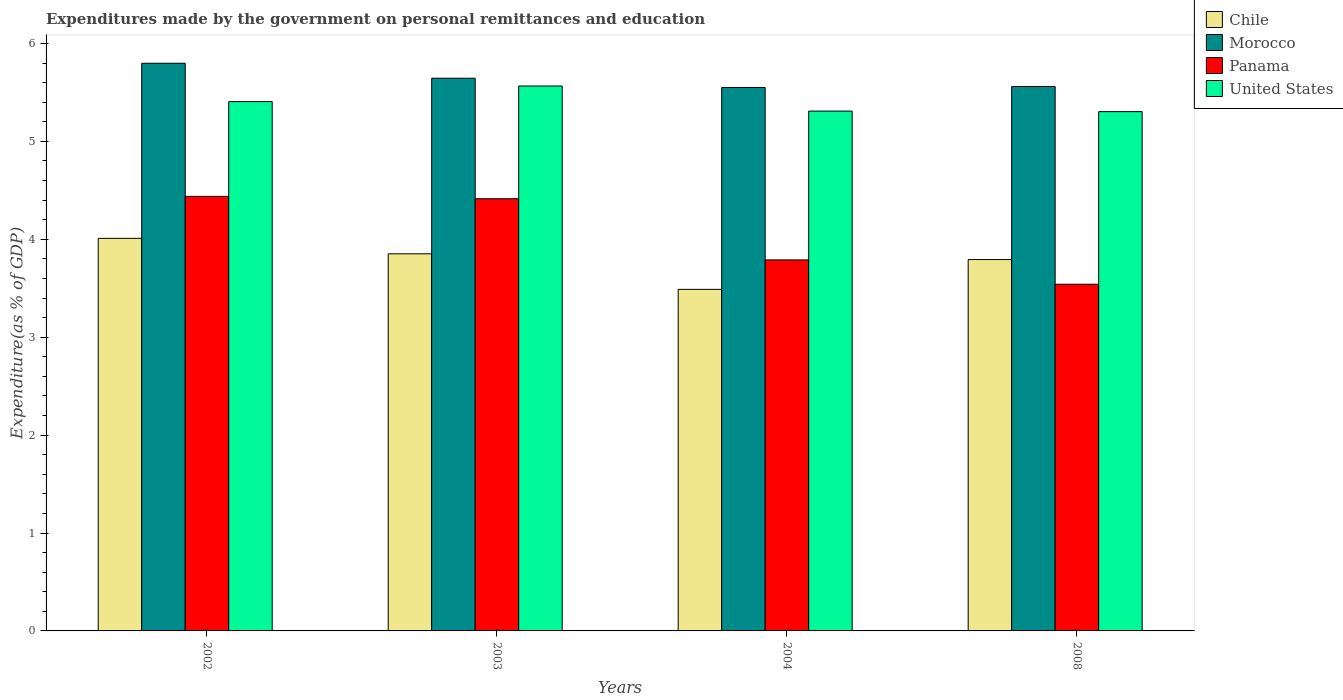How many different coloured bars are there?
Provide a succinct answer. 4. Are the number of bars per tick equal to the number of legend labels?
Your answer should be very brief. Yes. How many bars are there on the 4th tick from the left?
Ensure brevity in your answer.  4. In how many cases, is the number of bars for a given year not equal to the number of legend labels?
Your answer should be very brief. 0. What is the expenditures made by the government on personal remittances and education in Chile in 2004?
Offer a very short reply. 3.49. Across all years, what is the maximum expenditures made by the government on personal remittances and education in Panama?
Offer a very short reply. 4.44. Across all years, what is the minimum expenditures made by the government on personal remittances and education in Panama?
Provide a succinct answer. 3.54. What is the total expenditures made by the government on personal remittances and education in Panama in the graph?
Your answer should be very brief. 16.18. What is the difference between the expenditures made by the government on personal remittances and education in United States in 2002 and that in 2008?
Provide a succinct answer. 0.1. What is the difference between the expenditures made by the government on personal remittances and education in Panama in 2008 and the expenditures made by the government on personal remittances and education in United States in 2002?
Give a very brief answer. -1.87. What is the average expenditures made by the government on personal remittances and education in Morocco per year?
Ensure brevity in your answer.  5.64. In the year 2004, what is the difference between the expenditures made by the government on personal remittances and education in Chile and expenditures made by the government on personal remittances and education in Panama?
Offer a very short reply. -0.3. In how many years, is the expenditures made by the government on personal remittances and education in United States greater than 3.2 %?
Provide a short and direct response. 4. What is the ratio of the expenditures made by the government on personal remittances and education in Morocco in 2002 to that in 2008?
Your answer should be very brief. 1.04. Is the expenditures made by the government on personal remittances and education in United States in 2002 less than that in 2004?
Make the answer very short. No. What is the difference between the highest and the second highest expenditures made by the government on personal remittances and education in United States?
Ensure brevity in your answer.  0.16. What is the difference between the highest and the lowest expenditures made by the government on personal remittances and education in Chile?
Provide a succinct answer. 0.52. Is it the case that in every year, the sum of the expenditures made by the government on personal remittances and education in Morocco and expenditures made by the government on personal remittances and education in United States is greater than the sum of expenditures made by the government on personal remittances and education in Chile and expenditures made by the government on personal remittances and education in Panama?
Provide a short and direct response. Yes. What does the 2nd bar from the right in 2008 represents?
Your answer should be compact. Panama. Is it the case that in every year, the sum of the expenditures made by the government on personal remittances and education in Chile and expenditures made by the government on personal remittances and education in Morocco is greater than the expenditures made by the government on personal remittances and education in Panama?
Offer a very short reply. Yes. Are all the bars in the graph horizontal?
Offer a very short reply. No. How many years are there in the graph?
Your answer should be very brief. 4. Are the values on the major ticks of Y-axis written in scientific E-notation?
Ensure brevity in your answer.  No. How many legend labels are there?
Offer a very short reply. 4. How are the legend labels stacked?
Make the answer very short. Vertical. What is the title of the graph?
Make the answer very short. Expenditures made by the government on personal remittances and education. Does "Macao" appear as one of the legend labels in the graph?
Provide a short and direct response. No. What is the label or title of the X-axis?
Your response must be concise. Years. What is the label or title of the Y-axis?
Your answer should be compact. Expenditure(as % of GDP). What is the Expenditure(as % of GDP) in Chile in 2002?
Give a very brief answer. 4.01. What is the Expenditure(as % of GDP) in Morocco in 2002?
Make the answer very short. 5.8. What is the Expenditure(as % of GDP) of Panama in 2002?
Keep it short and to the point. 4.44. What is the Expenditure(as % of GDP) in United States in 2002?
Make the answer very short. 5.41. What is the Expenditure(as % of GDP) of Chile in 2003?
Provide a short and direct response. 3.85. What is the Expenditure(as % of GDP) of Morocco in 2003?
Ensure brevity in your answer.  5.64. What is the Expenditure(as % of GDP) of Panama in 2003?
Provide a short and direct response. 4.41. What is the Expenditure(as % of GDP) of United States in 2003?
Provide a short and direct response. 5.57. What is the Expenditure(as % of GDP) in Chile in 2004?
Ensure brevity in your answer.  3.49. What is the Expenditure(as % of GDP) of Morocco in 2004?
Offer a terse response. 5.55. What is the Expenditure(as % of GDP) of Panama in 2004?
Your response must be concise. 3.79. What is the Expenditure(as % of GDP) of United States in 2004?
Your response must be concise. 5.31. What is the Expenditure(as % of GDP) in Chile in 2008?
Provide a short and direct response. 3.79. What is the Expenditure(as % of GDP) in Morocco in 2008?
Provide a short and direct response. 5.56. What is the Expenditure(as % of GDP) in Panama in 2008?
Make the answer very short. 3.54. What is the Expenditure(as % of GDP) in United States in 2008?
Provide a short and direct response. 5.3. Across all years, what is the maximum Expenditure(as % of GDP) in Chile?
Your answer should be compact. 4.01. Across all years, what is the maximum Expenditure(as % of GDP) in Morocco?
Offer a terse response. 5.8. Across all years, what is the maximum Expenditure(as % of GDP) in Panama?
Offer a very short reply. 4.44. Across all years, what is the maximum Expenditure(as % of GDP) of United States?
Make the answer very short. 5.57. Across all years, what is the minimum Expenditure(as % of GDP) in Chile?
Provide a succinct answer. 3.49. Across all years, what is the minimum Expenditure(as % of GDP) in Morocco?
Your response must be concise. 5.55. Across all years, what is the minimum Expenditure(as % of GDP) of Panama?
Your response must be concise. 3.54. Across all years, what is the minimum Expenditure(as % of GDP) in United States?
Offer a very short reply. 5.3. What is the total Expenditure(as % of GDP) in Chile in the graph?
Provide a short and direct response. 15.14. What is the total Expenditure(as % of GDP) in Morocco in the graph?
Keep it short and to the point. 22.55. What is the total Expenditure(as % of GDP) of Panama in the graph?
Keep it short and to the point. 16.18. What is the total Expenditure(as % of GDP) of United States in the graph?
Ensure brevity in your answer.  21.58. What is the difference between the Expenditure(as % of GDP) of Chile in 2002 and that in 2003?
Offer a very short reply. 0.16. What is the difference between the Expenditure(as % of GDP) in Morocco in 2002 and that in 2003?
Offer a terse response. 0.15. What is the difference between the Expenditure(as % of GDP) in Panama in 2002 and that in 2003?
Offer a terse response. 0.02. What is the difference between the Expenditure(as % of GDP) in United States in 2002 and that in 2003?
Your answer should be very brief. -0.16. What is the difference between the Expenditure(as % of GDP) in Chile in 2002 and that in 2004?
Offer a very short reply. 0.52. What is the difference between the Expenditure(as % of GDP) of Morocco in 2002 and that in 2004?
Make the answer very short. 0.25. What is the difference between the Expenditure(as % of GDP) in Panama in 2002 and that in 2004?
Provide a short and direct response. 0.65. What is the difference between the Expenditure(as % of GDP) in United States in 2002 and that in 2004?
Offer a terse response. 0.1. What is the difference between the Expenditure(as % of GDP) in Chile in 2002 and that in 2008?
Provide a succinct answer. 0.22. What is the difference between the Expenditure(as % of GDP) in Morocco in 2002 and that in 2008?
Your answer should be compact. 0.24. What is the difference between the Expenditure(as % of GDP) in Panama in 2002 and that in 2008?
Your answer should be compact. 0.9. What is the difference between the Expenditure(as % of GDP) of United States in 2002 and that in 2008?
Provide a short and direct response. 0.1. What is the difference between the Expenditure(as % of GDP) in Chile in 2003 and that in 2004?
Your answer should be compact. 0.36. What is the difference between the Expenditure(as % of GDP) in Morocco in 2003 and that in 2004?
Make the answer very short. 0.09. What is the difference between the Expenditure(as % of GDP) in Panama in 2003 and that in 2004?
Keep it short and to the point. 0.62. What is the difference between the Expenditure(as % of GDP) of United States in 2003 and that in 2004?
Your response must be concise. 0.26. What is the difference between the Expenditure(as % of GDP) in Chile in 2003 and that in 2008?
Offer a terse response. 0.06. What is the difference between the Expenditure(as % of GDP) of Morocco in 2003 and that in 2008?
Your answer should be compact. 0.08. What is the difference between the Expenditure(as % of GDP) of Panama in 2003 and that in 2008?
Provide a succinct answer. 0.87. What is the difference between the Expenditure(as % of GDP) of United States in 2003 and that in 2008?
Provide a short and direct response. 0.26. What is the difference between the Expenditure(as % of GDP) of Chile in 2004 and that in 2008?
Provide a succinct answer. -0.3. What is the difference between the Expenditure(as % of GDP) in Morocco in 2004 and that in 2008?
Ensure brevity in your answer.  -0.01. What is the difference between the Expenditure(as % of GDP) of Panama in 2004 and that in 2008?
Your response must be concise. 0.25. What is the difference between the Expenditure(as % of GDP) of United States in 2004 and that in 2008?
Provide a short and direct response. 0.01. What is the difference between the Expenditure(as % of GDP) of Chile in 2002 and the Expenditure(as % of GDP) of Morocco in 2003?
Make the answer very short. -1.64. What is the difference between the Expenditure(as % of GDP) in Chile in 2002 and the Expenditure(as % of GDP) in Panama in 2003?
Offer a very short reply. -0.4. What is the difference between the Expenditure(as % of GDP) in Chile in 2002 and the Expenditure(as % of GDP) in United States in 2003?
Provide a short and direct response. -1.56. What is the difference between the Expenditure(as % of GDP) of Morocco in 2002 and the Expenditure(as % of GDP) of Panama in 2003?
Ensure brevity in your answer.  1.38. What is the difference between the Expenditure(as % of GDP) in Morocco in 2002 and the Expenditure(as % of GDP) in United States in 2003?
Keep it short and to the point. 0.23. What is the difference between the Expenditure(as % of GDP) of Panama in 2002 and the Expenditure(as % of GDP) of United States in 2003?
Offer a very short reply. -1.13. What is the difference between the Expenditure(as % of GDP) in Chile in 2002 and the Expenditure(as % of GDP) in Morocco in 2004?
Offer a very short reply. -1.54. What is the difference between the Expenditure(as % of GDP) of Chile in 2002 and the Expenditure(as % of GDP) of Panama in 2004?
Provide a succinct answer. 0.22. What is the difference between the Expenditure(as % of GDP) in Chile in 2002 and the Expenditure(as % of GDP) in United States in 2004?
Your answer should be very brief. -1.3. What is the difference between the Expenditure(as % of GDP) in Morocco in 2002 and the Expenditure(as % of GDP) in Panama in 2004?
Make the answer very short. 2.01. What is the difference between the Expenditure(as % of GDP) in Morocco in 2002 and the Expenditure(as % of GDP) in United States in 2004?
Your answer should be very brief. 0.49. What is the difference between the Expenditure(as % of GDP) in Panama in 2002 and the Expenditure(as % of GDP) in United States in 2004?
Provide a short and direct response. -0.87. What is the difference between the Expenditure(as % of GDP) of Chile in 2002 and the Expenditure(as % of GDP) of Morocco in 2008?
Offer a very short reply. -1.55. What is the difference between the Expenditure(as % of GDP) of Chile in 2002 and the Expenditure(as % of GDP) of Panama in 2008?
Provide a short and direct response. 0.47. What is the difference between the Expenditure(as % of GDP) of Chile in 2002 and the Expenditure(as % of GDP) of United States in 2008?
Give a very brief answer. -1.29. What is the difference between the Expenditure(as % of GDP) of Morocco in 2002 and the Expenditure(as % of GDP) of Panama in 2008?
Provide a short and direct response. 2.26. What is the difference between the Expenditure(as % of GDP) in Morocco in 2002 and the Expenditure(as % of GDP) in United States in 2008?
Your answer should be compact. 0.49. What is the difference between the Expenditure(as % of GDP) of Panama in 2002 and the Expenditure(as % of GDP) of United States in 2008?
Your response must be concise. -0.87. What is the difference between the Expenditure(as % of GDP) of Chile in 2003 and the Expenditure(as % of GDP) of Morocco in 2004?
Your answer should be very brief. -1.7. What is the difference between the Expenditure(as % of GDP) in Chile in 2003 and the Expenditure(as % of GDP) in Panama in 2004?
Offer a very short reply. 0.06. What is the difference between the Expenditure(as % of GDP) of Chile in 2003 and the Expenditure(as % of GDP) of United States in 2004?
Offer a very short reply. -1.46. What is the difference between the Expenditure(as % of GDP) in Morocco in 2003 and the Expenditure(as % of GDP) in Panama in 2004?
Provide a succinct answer. 1.86. What is the difference between the Expenditure(as % of GDP) of Morocco in 2003 and the Expenditure(as % of GDP) of United States in 2004?
Make the answer very short. 0.34. What is the difference between the Expenditure(as % of GDP) of Panama in 2003 and the Expenditure(as % of GDP) of United States in 2004?
Your answer should be very brief. -0.9. What is the difference between the Expenditure(as % of GDP) in Chile in 2003 and the Expenditure(as % of GDP) in Morocco in 2008?
Provide a succinct answer. -1.71. What is the difference between the Expenditure(as % of GDP) in Chile in 2003 and the Expenditure(as % of GDP) in Panama in 2008?
Provide a succinct answer. 0.31. What is the difference between the Expenditure(as % of GDP) in Chile in 2003 and the Expenditure(as % of GDP) in United States in 2008?
Provide a succinct answer. -1.45. What is the difference between the Expenditure(as % of GDP) in Morocco in 2003 and the Expenditure(as % of GDP) in Panama in 2008?
Keep it short and to the point. 2.1. What is the difference between the Expenditure(as % of GDP) in Morocco in 2003 and the Expenditure(as % of GDP) in United States in 2008?
Keep it short and to the point. 0.34. What is the difference between the Expenditure(as % of GDP) in Panama in 2003 and the Expenditure(as % of GDP) in United States in 2008?
Give a very brief answer. -0.89. What is the difference between the Expenditure(as % of GDP) of Chile in 2004 and the Expenditure(as % of GDP) of Morocco in 2008?
Your answer should be very brief. -2.07. What is the difference between the Expenditure(as % of GDP) in Chile in 2004 and the Expenditure(as % of GDP) in Panama in 2008?
Offer a terse response. -0.05. What is the difference between the Expenditure(as % of GDP) of Chile in 2004 and the Expenditure(as % of GDP) of United States in 2008?
Provide a short and direct response. -1.82. What is the difference between the Expenditure(as % of GDP) in Morocco in 2004 and the Expenditure(as % of GDP) in Panama in 2008?
Offer a very short reply. 2.01. What is the difference between the Expenditure(as % of GDP) in Morocco in 2004 and the Expenditure(as % of GDP) in United States in 2008?
Provide a short and direct response. 0.25. What is the difference between the Expenditure(as % of GDP) of Panama in 2004 and the Expenditure(as % of GDP) of United States in 2008?
Give a very brief answer. -1.51. What is the average Expenditure(as % of GDP) in Chile per year?
Provide a short and direct response. 3.79. What is the average Expenditure(as % of GDP) in Morocco per year?
Your response must be concise. 5.64. What is the average Expenditure(as % of GDP) of Panama per year?
Offer a terse response. 4.05. What is the average Expenditure(as % of GDP) in United States per year?
Offer a terse response. 5.4. In the year 2002, what is the difference between the Expenditure(as % of GDP) of Chile and Expenditure(as % of GDP) of Morocco?
Offer a terse response. -1.79. In the year 2002, what is the difference between the Expenditure(as % of GDP) in Chile and Expenditure(as % of GDP) in Panama?
Offer a very short reply. -0.43. In the year 2002, what is the difference between the Expenditure(as % of GDP) of Chile and Expenditure(as % of GDP) of United States?
Keep it short and to the point. -1.4. In the year 2002, what is the difference between the Expenditure(as % of GDP) of Morocco and Expenditure(as % of GDP) of Panama?
Your answer should be very brief. 1.36. In the year 2002, what is the difference between the Expenditure(as % of GDP) in Morocco and Expenditure(as % of GDP) in United States?
Give a very brief answer. 0.39. In the year 2002, what is the difference between the Expenditure(as % of GDP) in Panama and Expenditure(as % of GDP) in United States?
Make the answer very short. -0.97. In the year 2003, what is the difference between the Expenditure(as % of GDP) of Chile and Expenditure(as % of GDP) of Morocco?
Provide a succinct answer. -1.79. In the year 2003, what is the difference between the Expenditure(as % of GDP) of Chile and Expenditure(as % of GDP) of Panama?
Offer a very short reply. -0.56. In the year 2003, what is the difference between the Expenditure(as % of GDP) of Chile and Expenditure(as % of GDP) of United States?
Provide a succinct answer. -1.71. In the year 2003, what is the difference between the Expenditure(as % of GDP) of Morocco and Expenditure(as % of GDP) of Panama?
Provide a succinct answer. 1.23. In the year 2003, what is the difference between the Expenditure(as % of GDP) in Morocco and Expenditure(as % of GDP) in United States?
Ensure brevity in your answer.  0.08. In the year 2003, what is the difference between the Expenditure(as % of GDP) in Panama and Expenditure(as % of GDP) in United States?
Make the answer very short. -1.15. In the year 2004, what is the difference between the Expenditure(as % of GDP) of Chile and Expenditure(as % of GDP) of Morocco?
Provide a succinct answer. -2.06. In the year 2004, what is the difference between the Expenditure(as % of GDP) of Chile and Expenditure(as % of GDP) of Panama?
Your response must be concise. -0.3. In the year 2004, what is the difference between the Expenditure(as % of GDP) in Chile and Expenditure(as % of GDP) in United States?
Make the answer very short. -1.82. In the year 2004, what is the difference between the Expenditure(as % of GDP) of Morocco and Expenditure(as % of GDP) of Panama?
Provide a short and direct response. 1.76. In the year 2004, what is the difference between the Expenditure(as % of GDP) in Morocco and Expenditure(as % of GDP) in United States?
Ensure brevity in your answer.  0.24. In the year 2004, what is the difference between the Expenditure(as % of GDP) in Panama and Expenditure(as % of GDP) in United States?
Provide a short and direct response. -1.52. In the year 2008, what is the difference between the Expenditure(as % of GDP) in Chile and Expenditure(as % of GDP) in Morocco?
Offer a terse response. -1.77. In the year 2008, what is the difference between the Expenditure(as % of GDP) in Chile and Expenditure(as % of GDP) in Panama?
Your answer should be very brief. 0.25. In the year 2008, what is the difference between the Expenditure(as % of GDP) in Chile and Expenditure(as % of GDP) in United States?
Offer a very short reply. -1.51. In the year 2008, what is the difference between the Expenditure(as % of GDP) of Morocco and Expenditure(as % of GDP) of Panama?
Provide a succinct answer. 2.02. In the year 2008, what is the difference between the Expenditure(as % of GDP) of Morocco and Expenditure(as % of GDP) of United States?
Make the answer very short. 0.26. In the year 2008, what is the difference between the Expenditure(as % of GDP) in Panama and Expenditure(as % of GDP) in United States?
Provide a succinct answer. -1.76. What is the ratio of the Expenditure(as % of GDP) of Chile in 2002 to that in 2003?
Give a very brief answer. 1.04. What is the ratio of the Expenditure(as % of GDP) of Morocco in 2002 to that in 2003?
Offer a terse response. 1.03. What is the ratio of the Expenditure(as % of GDP) of Panama in 2002 to that in 2003?
Ensure brevity in your answer.  1.01. What is the ratio of the Expenditure(as % of GDP) of United States in 2002 to that in 2003?
Give a very brief answer. 0.97. What is the ratio of the Expenditure(as % of GDP) in Chile in 2002 to that in 2004?
Offer a very short reply. 1.15. What is the ratio of the Expenditure(as % of GDP) in Morocco in 2002 to that in 2004?
Your response must be concise. 1.04. What is the ratio of the Expenditure(as % of GDP) in Panama in 2002 to that in 2004?
Ensure brevity in your answer.  1.17. What is the ratio of the Expenditure(as % of GDP) in United States in 2002 to that in 2004?
Give a very brief answer. 1.02. What is the ratio of the Expenditure(as % of GDP) in Chile in 2002 to that in 2008?
Provide a short and direct response. 1.06. What is the ratio of the Expenditure(as % of GDP) of Morocco in 2002 to that in 2008?
Provide a short and direct response. 1.04. What is the ratio of the Expenditure(as % of GDP) in Panama in 2002 to that in 2008?
Provide a succinct answer. 1.25. What is the ratio of the Expenditure(as % of GDP) in United States in 2002 to that in 2008?
Provide a short and direct response. 1.02. What is the ratio of the Expenditure(as % of GDP) in Chile in 2003 to that in 2004?
Offer a terse response. 1.1. What is the ratio of the Expenditure(as % of GDP) in Morocco in 2003 to that in 2004?
Your answer should be compact. 1.02. What is the ratio of the Expenditure(as % of GDP) in Panama in 2003 to that in 2004?
Offer a terse response. 1.16. What is the ratio of the Expenditure(as % of GDP) of United States in 2003 to that in 2004?
Your response must be concise. 1.05. What is the ratio of the Expenditure(as % of GDP) of Chile in 2003 to that in 2008?
Ensure brevity in your answer.  1.02. What is the ratio of the Expenditure(as % of GDP) in Morocco in 2003 to that in 2008?
Your answer should be very brief. 1.02. What is the ratio of the Expenditure(as % of GDP) in Panama in 2003 to that in 2008?
Make the answer very short. 1.25. What is the ratio of the Expenditure(as % of GDP) of United States in 2003 to that in 2008?
Make the answer very short. 1.05. What is the ratio of the Expenditure(as % of GDP) of Chile in 2004 to that in 2008?
Your answer should be compact. 0.92. What is the ratio of the Expenditure(as % of GDP) in Panama in 2004 to that in 2008?
Make the answer very short. 1.07. What is the ratio of the Expenditure(as % of GDP) of United States in 2004 to that in 2008?
Your answer should be compact. 1. What is the difference between the highest and the second highest Expenditure(as % of GDP) in Chile?
Provide a succinct answer. 0.16. What is the difference between the highest and the second highest Expenditure(as % of GDP) in Morocco?
Provide a short and direct response. 0.15. What is the difference between the highest and the second highest Expenditure(as % of GDP) in Panama?
Make the answer very short. 0.02. What is the difference between the highest and the second highest Expenditure(as % of GDP) in United States?
Offer a very short reply. 0.16. What is the difference between the highest and the lowest Expenditure(as % of GDP) of Chile?
Keep it short and to the point. 0.52. What is the difference between the highest and the lowest Expenditure(as % of GDP) of Morocco?
Give a very brief answer. 0.25. What is the difference between the highest and the lowest Expenditure(as % of GDP) in Panama?
Provide a short and direct response. 0.9. What is the difference between the highest and the lowest Expenditure(as % of GDP) of United States?
Make the answer very short. 0.26. 